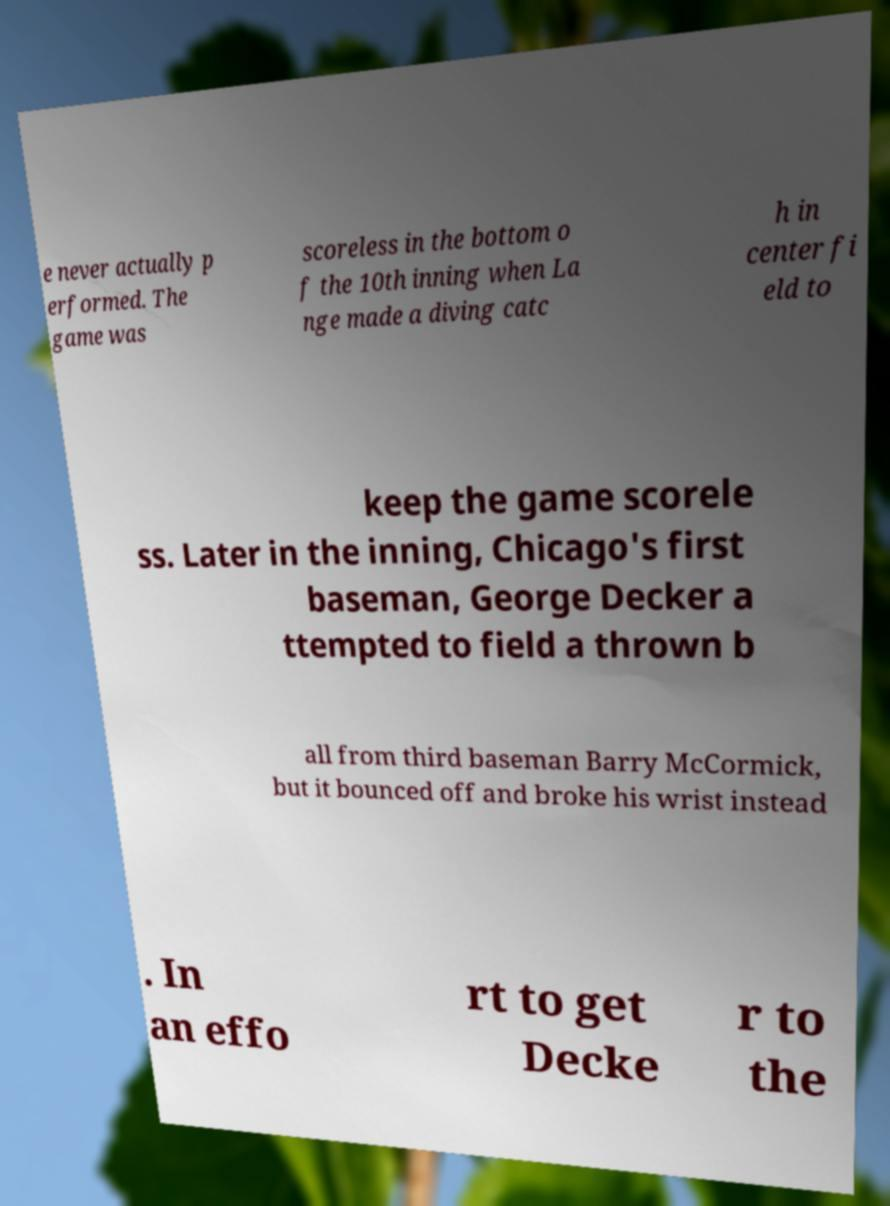Please read and relay the text visible in this image. What does it say? e never actually p erformed. The game was scoreless in the bottom o f the 10th inning when La nge made a diving catc h in center fi eld to keep the game scorele ss. Later in the inning, Chicago's first baseman, George Decker a ttempted to field a thrown b all from third baseman Barry McCormick, but it bounced off and broke his wrist instead . In an effo rt to get Decke r to the 